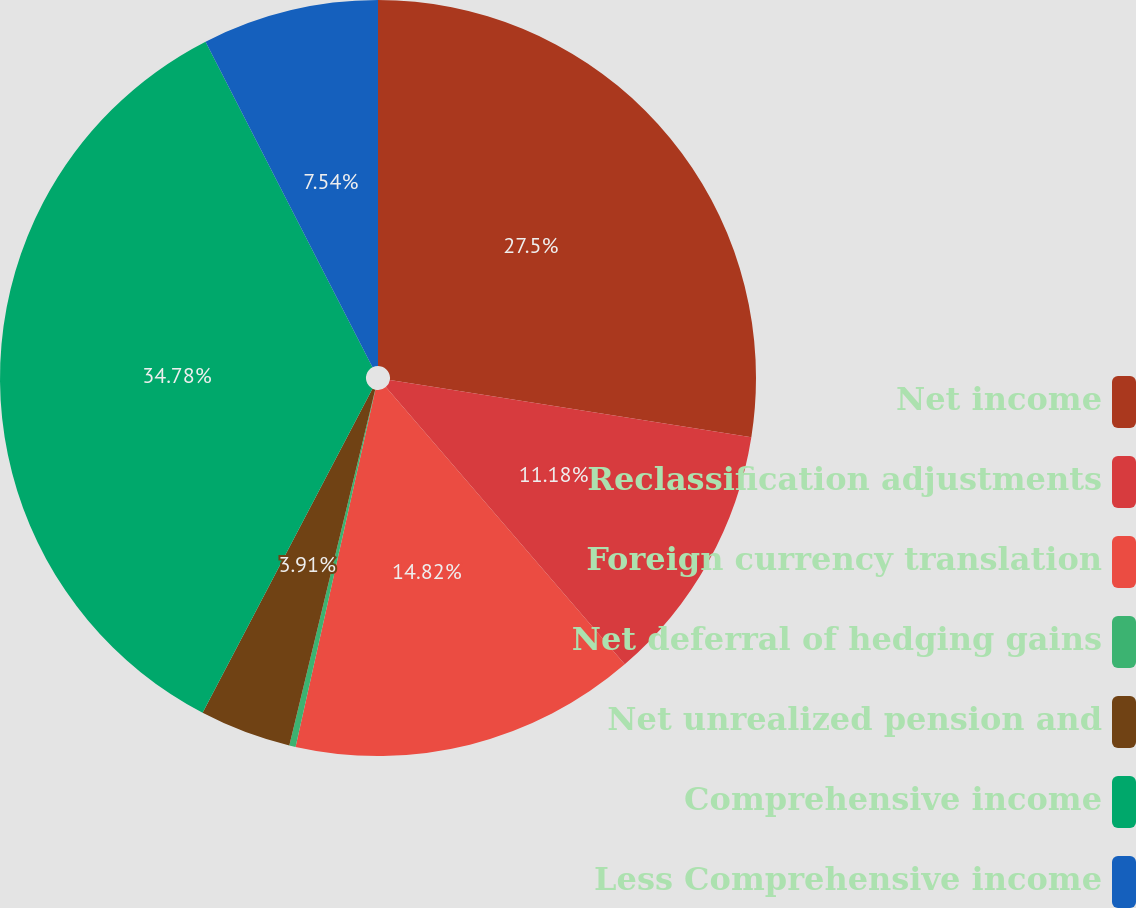Convert chart to OTSL. <chart><loc_0><loc_0><loc_500><loc_500><pie_chart><fcel>Net income<fcel>Reclassification adjustments<fcel>Foreign currency translation<fcel>Net deferral of hedging gains<fcel>Net unrealized pension and<fcel>Comprehensive income<fcel>Less Comprehensive income<nl><fcel>27.5%<fcel>11.18%<fcel>14.82%<fcel>0.27%<fcel>3.91%<fcel>34.78%<fcel>7.54%<nl></chart> 